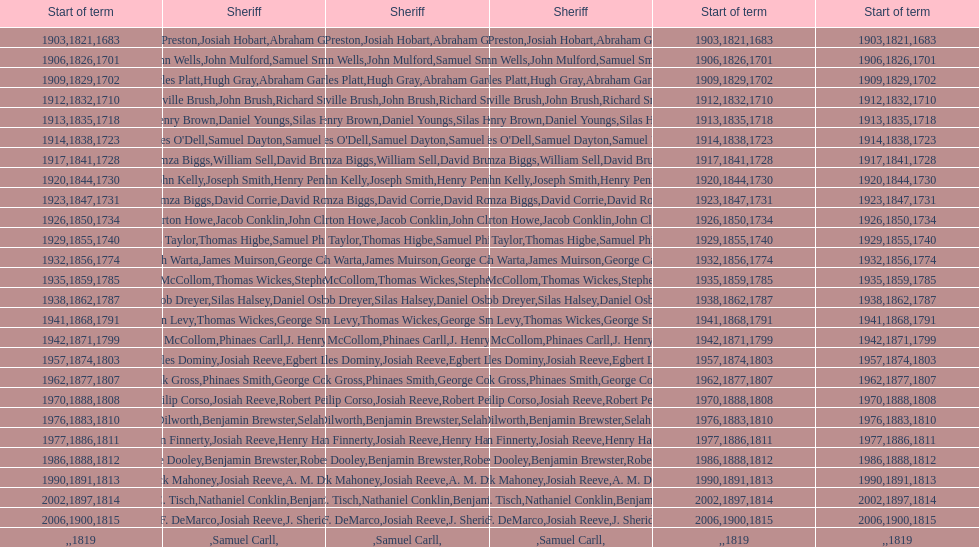When did the first sheriff's term start? 1683. 